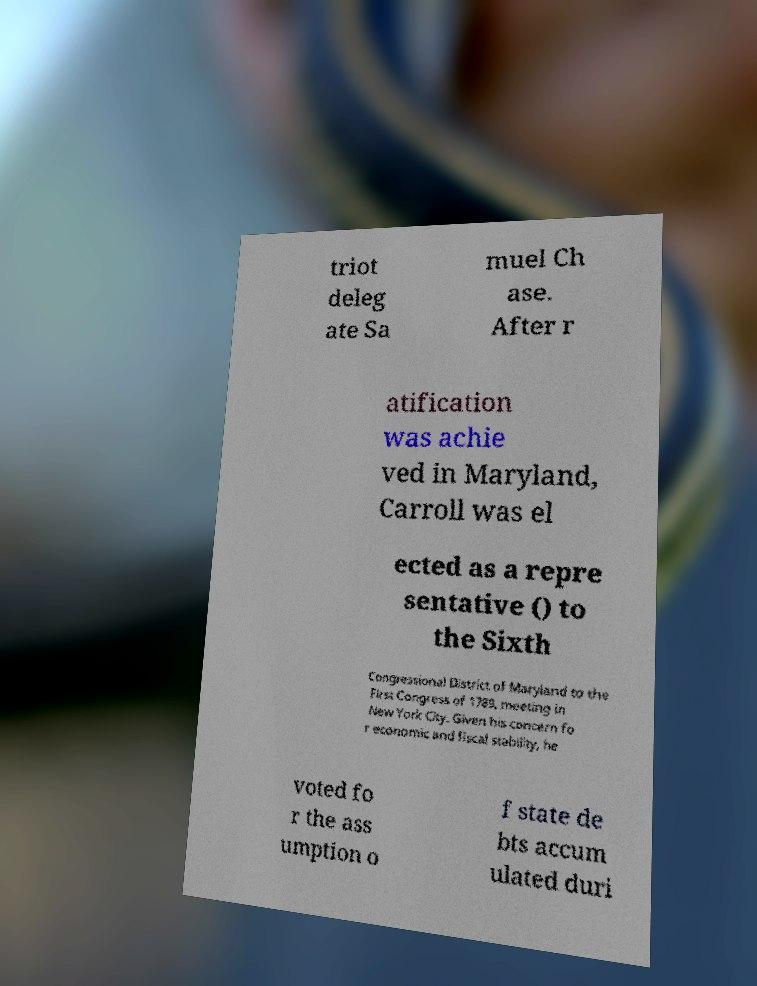For documentation purposes, I need the text within this image transcribed. Could you provide that? triot deleg ate Sa muel Ch ase. After r atification was achie ved in Maryland, Carroll was el ected as a repre sentative () to the Sixth Congressional District of Maryland to the First Congress of 1789, meeting in New York City. Given his concern fo r economic and fiscal stability, he voted fo r the ass umption o f state de bts accum ulated duri 